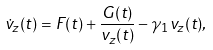<formula> <loc_0><loc_0><loc_500><loc_500>\dot { v } _ { z } ( t ) = F ( t ) + \frac { G ( t ) } { v _ { z } ( t ) } - \gamma _ { 1 } v _ { z } ( t ) ,</formula> 